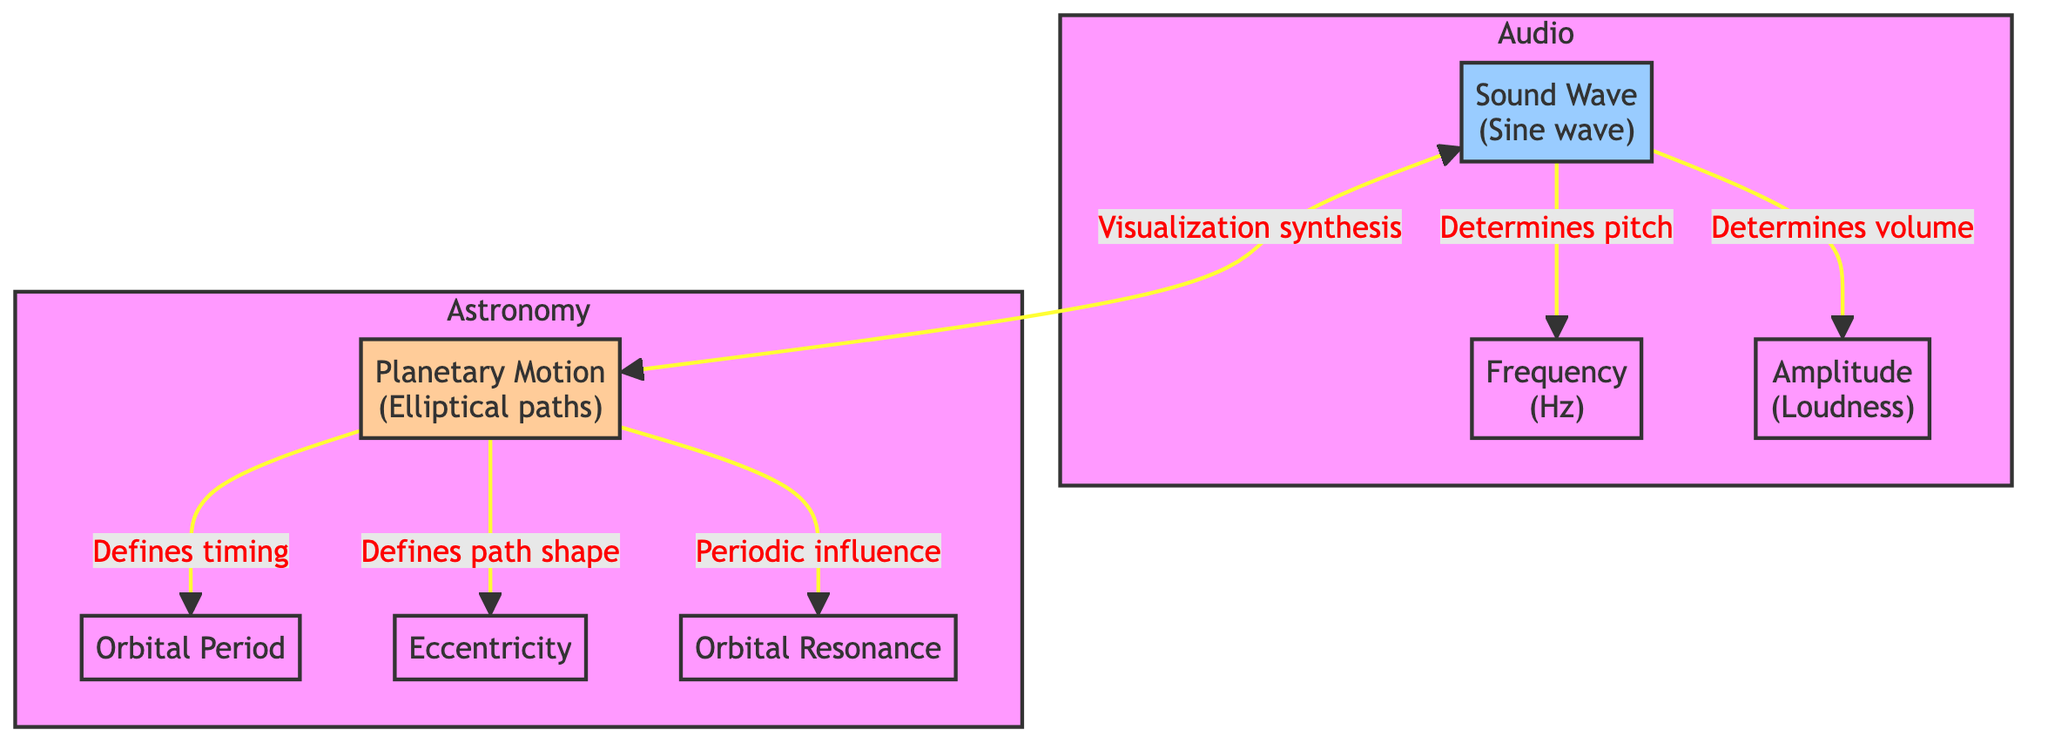What are the elements in the Audio subgraph? The Audio subgraph contains three elements: Sound Wave, Frequency, and Amplitude. These elements are visually grouped together, indicating they are related to sound.
Answer: Sound Wave, Frequency, Amplitude What does sound wave determine in the diagram? The diagram shows that the sound wave determines two aspects: pitch (through frequency) and volume (through amplitude). This means that both frequency and amplitude are influenced directly by the characteristics of the sound wave.
Answer: Pitch, Volume How many nodes are in the Astronomy subgraph? The Astronomy subgraph includes four nodes: Planetary Motion, Orbital Period, Eccentricity, and Resonance. Therefore, the total count of nodes in this subgraph is four.
Answer: 4 What is the relationship between planet motion and resonance? The diagram indicates a connection, stating that planet motion has a periodic influence on resonance. This implies that the motion of planets impacts the resonance experienced in the system.
Answer: Periodic influence What defines the path shape of planetary motion? According to the diagram, the eccentricity defines the path shape of planetary motion, which indicates that the shape of the orbit is influenced by the planet's eccentricity value.
Answer: Eccentricity What determines volume in the diagram? The sound wave component of the diagram determines the volume, which is represented as amplitude. Therefore, amplitude is the measure that represents sound loudness.
Answer: Amplitude What does the sound wave create in relation to planetary motion? The sound wave leads to a synthesis of visualization with planetary motion, implying that auditory experiences can be translated into visual representations of how planets move.
Answer: Visualization synthesis What is the significance of orbital period in planetary motion? The orbital period defines the timing of how long it takes for a planet to complete one full orbit. This is a key element that provides information about the planet's motion over time.
Answer: Timing What influences pitch in the diagram? Pitch is influenced by frequency as shown in the diagram. It indicates that the frequency of sound waves plays a crucial role in determining how high or low a sound is perceived.
Answer: Frequency 